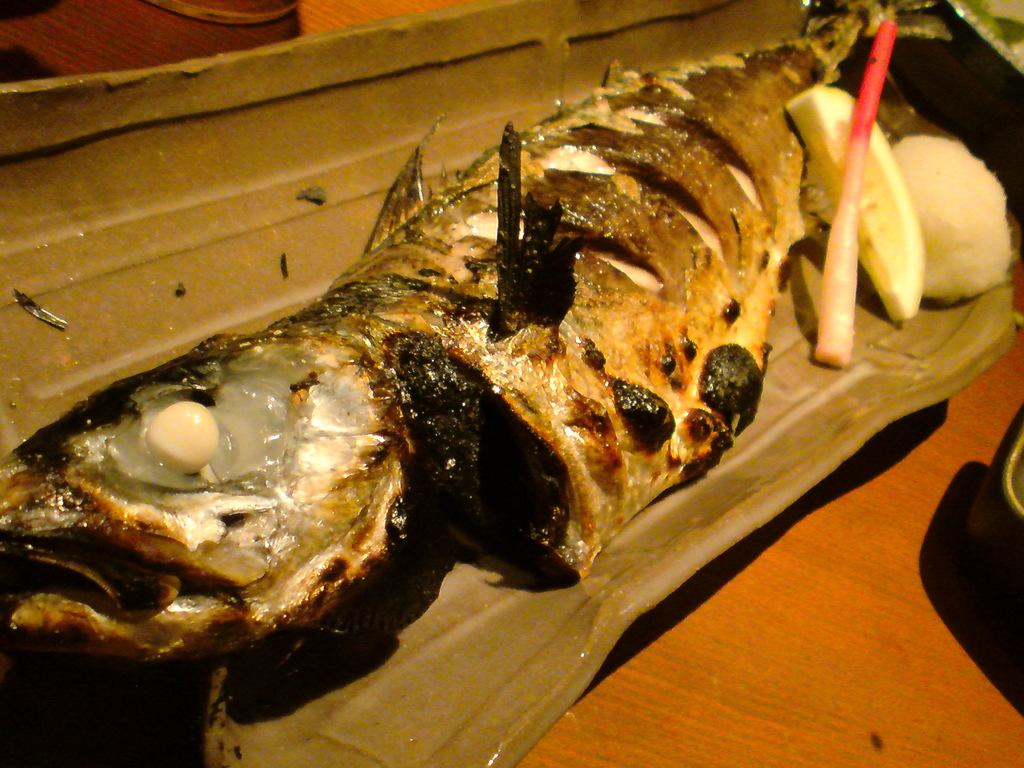What type of food can be seen in the image? There is food in the image, but the specific type is not mentioned. What is placed on the food in the image? There is a lemon slice in the image. On what surface is the object with the lemon slice placed? The object with the lemon slice is on a wooden surface. Can you describe the unspecified items on the right side and top of the image? Unfortunately, the facts provided do not give any details about the unspecified items on the right side and top of the image. What invention is being used to limit the amount of flesh in the image? There is no mention of any invention, flesh, or limitation in the image. 